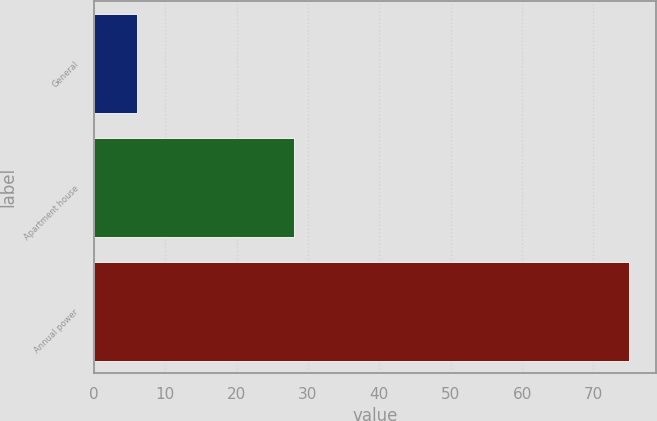Convert chart to OTSL. <chart><loc_0><loc_0><loc_500><loc_500><bar_chart><fcel>General<fcel>Apartment house<fcel>Annual power<nl><fcel>6<fcel>28<fcel>75<nl></chart> 